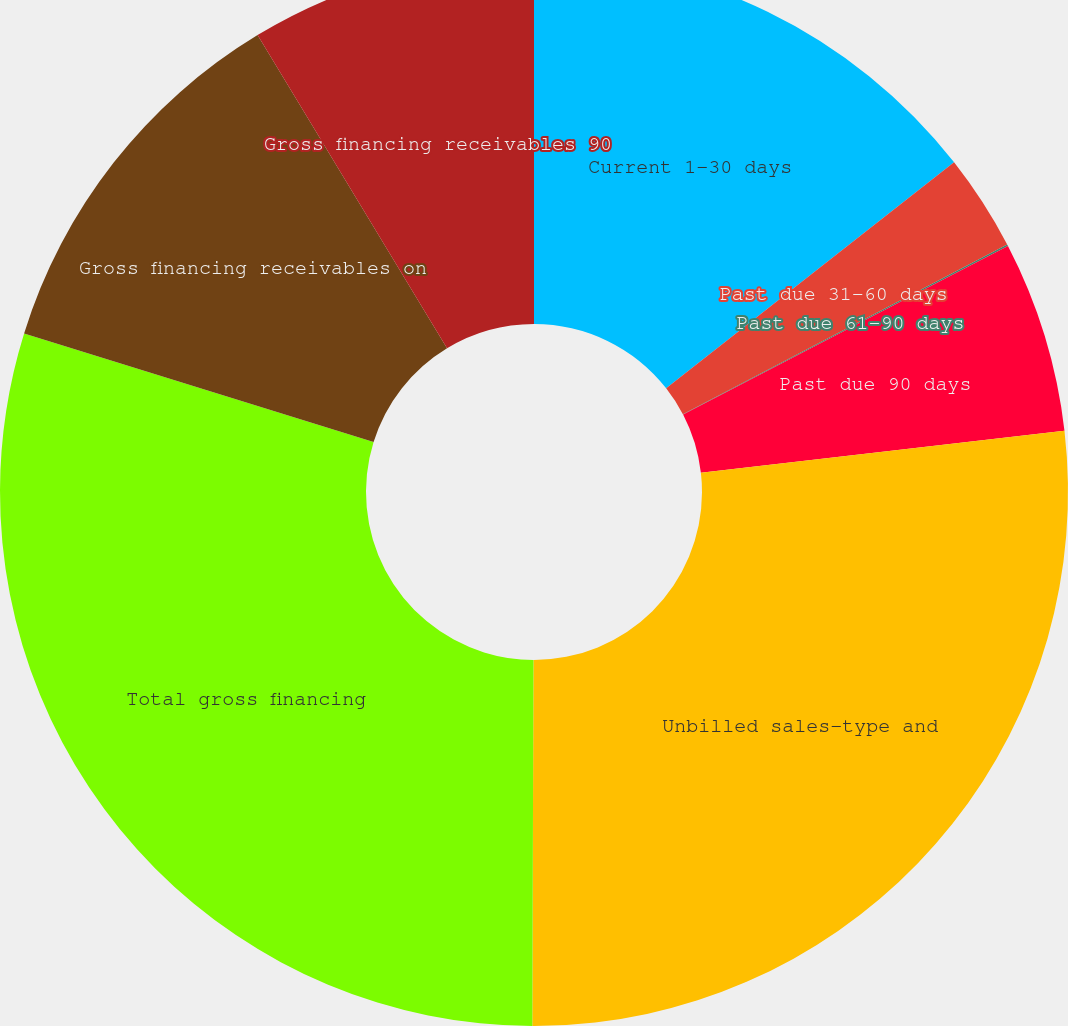Convert chart. <chart><loc_0><loc_0><loc_500><loc_500><pie_chart><fcel>Current 1-30 days<fcel>Past due 31-60 days<fcel>Past due 61-90 days<fcel>Past due 90 days<fcel>Unbilled sales-type and<fcel>Total gross financing<fcel>Gross financing receivables on<fcel>Gross financing receivables 90<nl><fcel>14.41%<fcel>2.92%<fcel>0.05%<fcel>5.79%<fcel>26.88%<fcel>29.75%<fcel>11.54%<fcel>8.66%<nl></chart> 